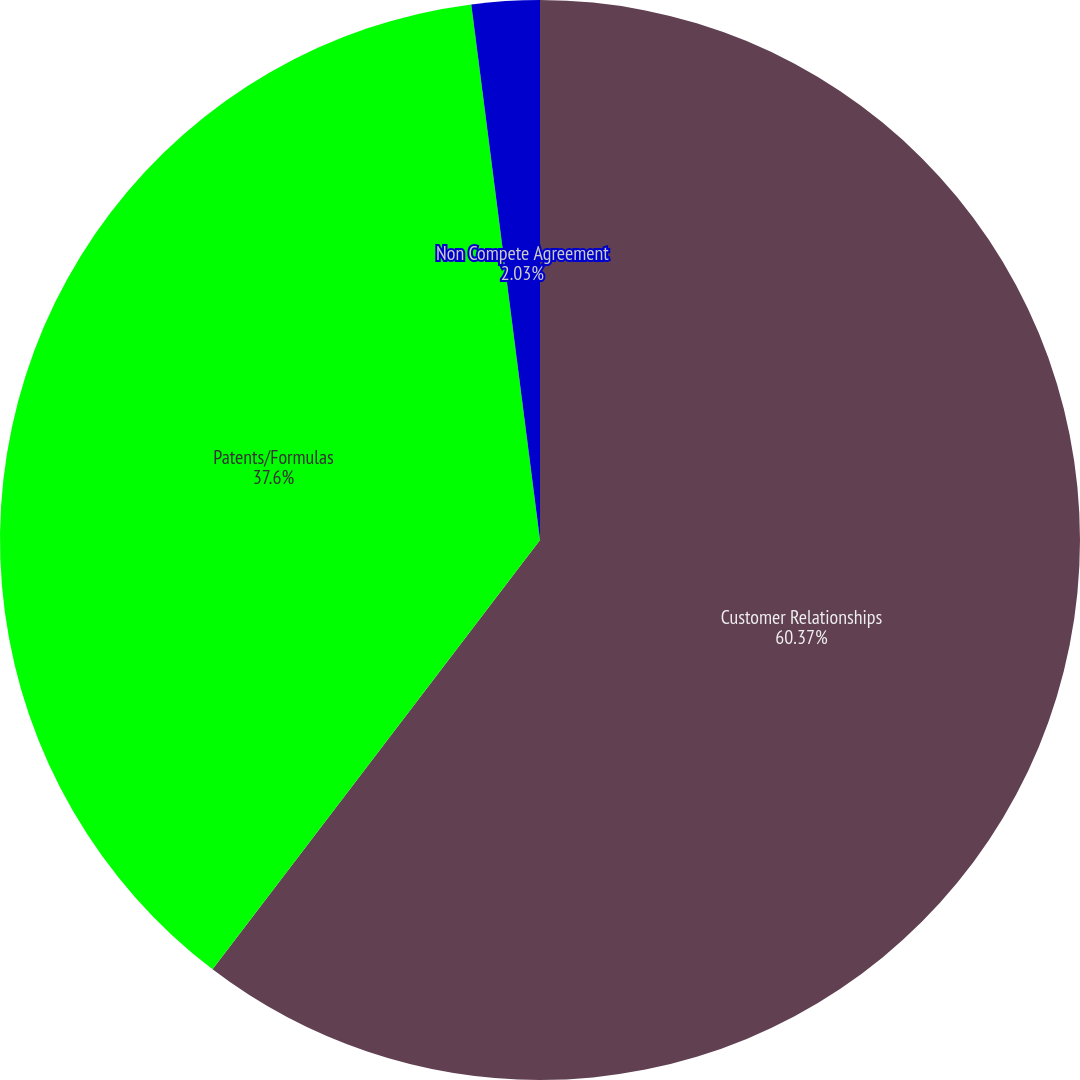Convert chart. <chart><loc_0><loc_0><loc_500><loc_500><pie_chart><fcel>Customer Relationships<fcel>Patents/Formulas<fcel>Non Compete Agreement<nl><fcel>60.37%<fcel>37.6%<fcel>2.03%<nl></chart> 